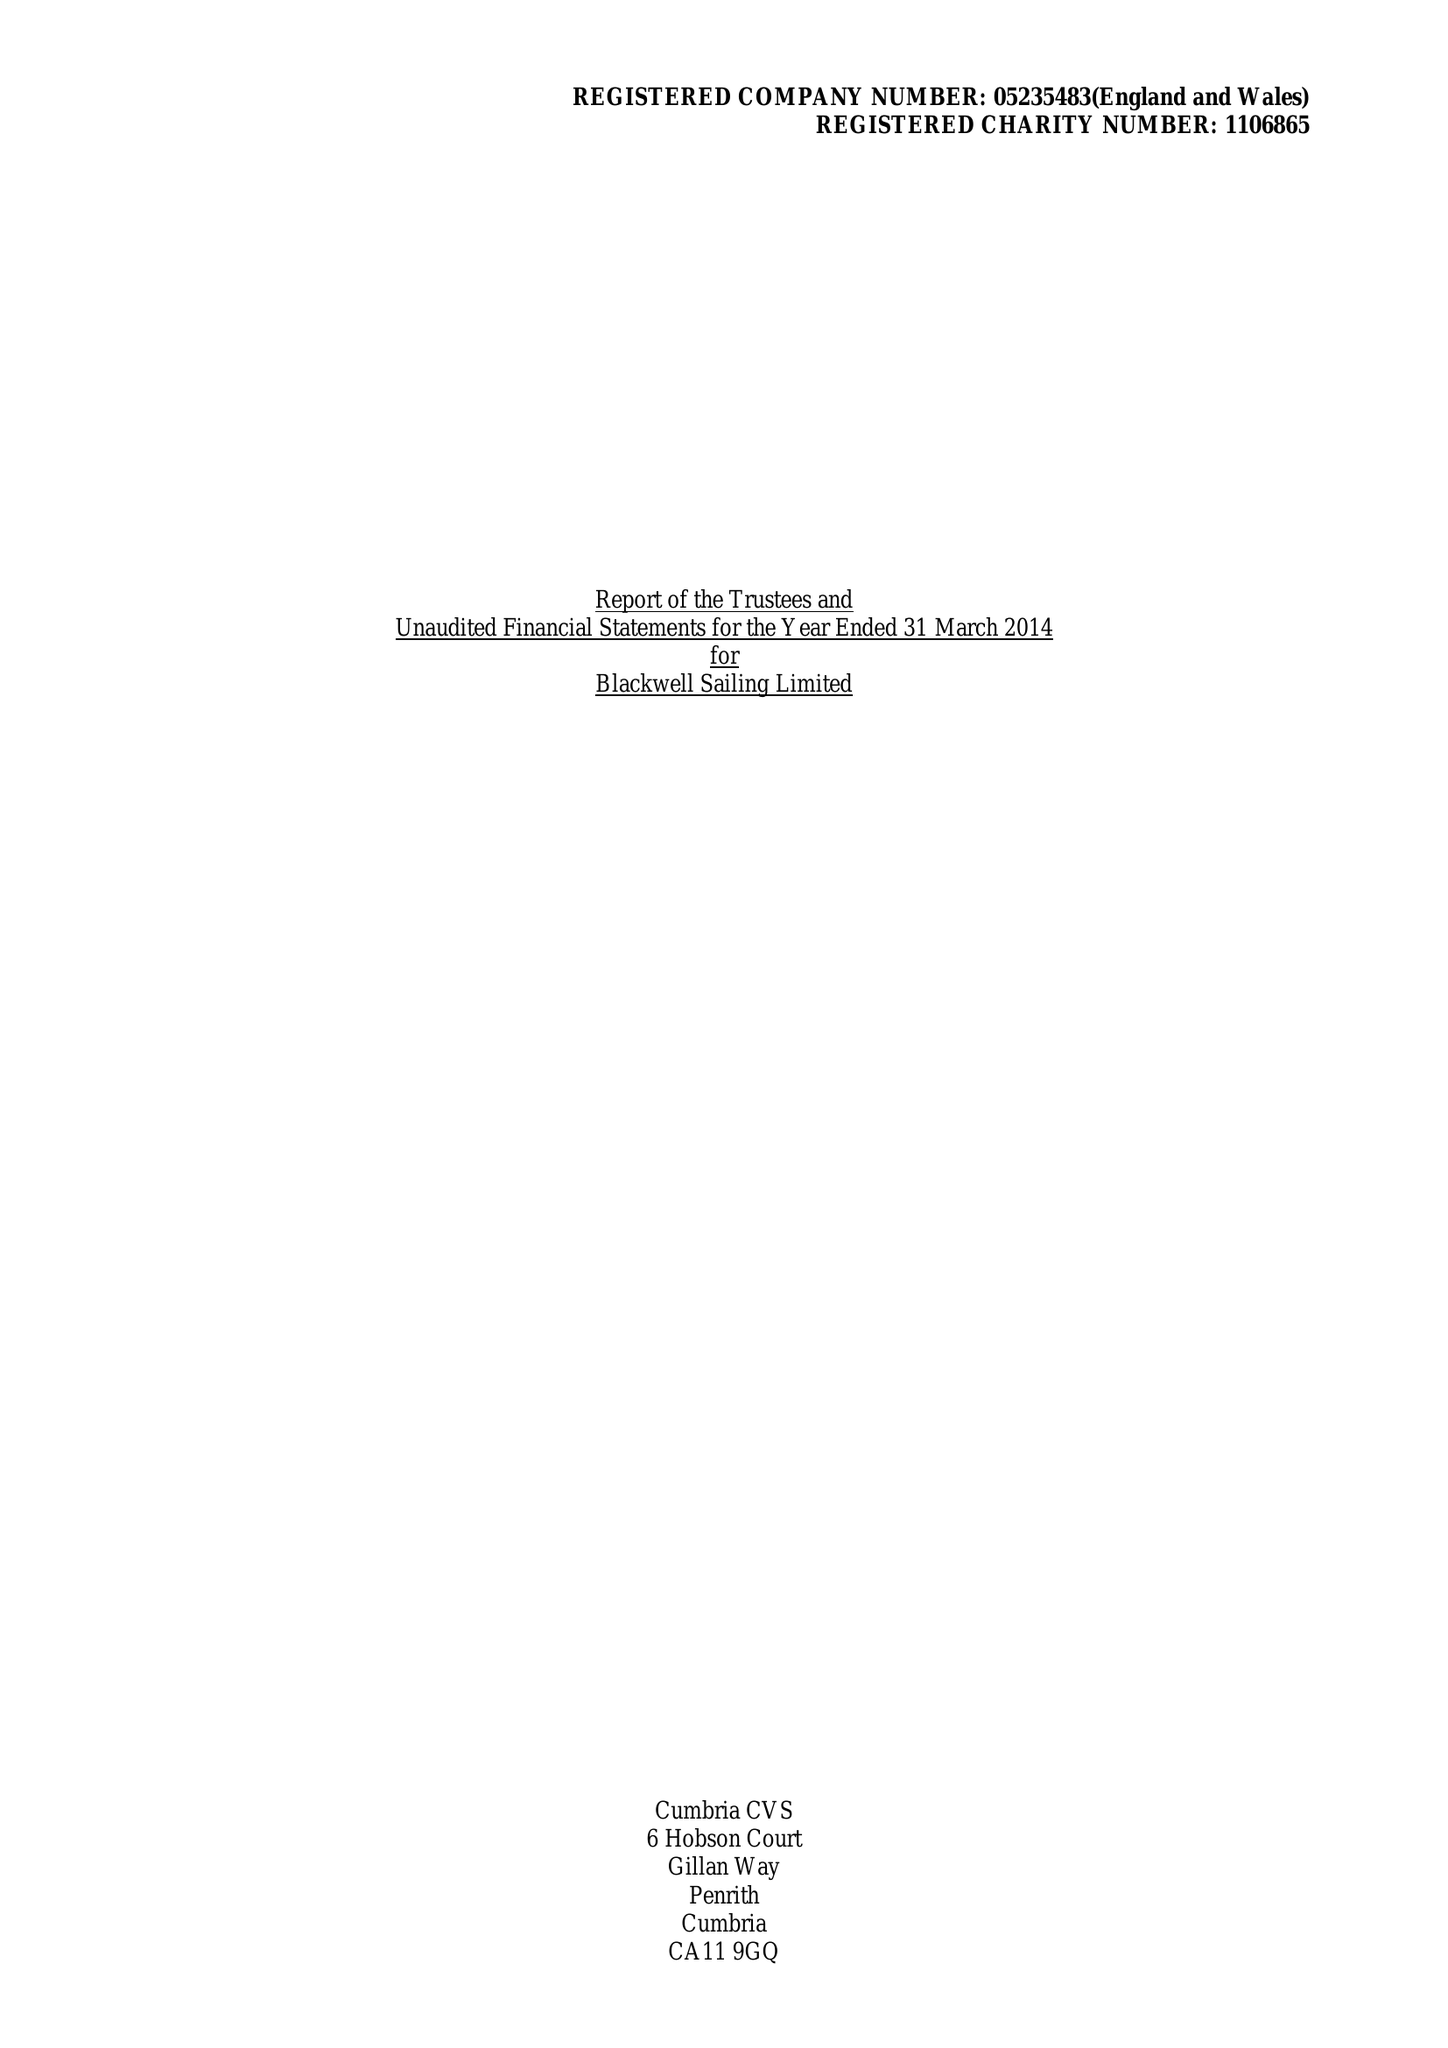What is the value for the charity_name?
Answer the question using a single word or phrase. Blackwell Sailing Ltd. 